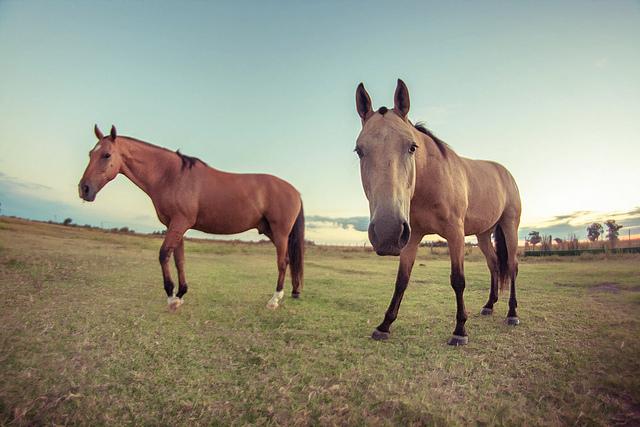Is the horse looking at the camera?
Answer briefly. Yes. Does the grass need to be trimmed?
Keep it brief. No. Are the horses walking?
Keep it brief. No. Has the horse been tied?
Short answer required. No. Are the shadows overpowering the photo?
Concise answer only. No. What is the horses looking at?
Answer briefly. Camera. Are the horses on a hillside?
Short answer required. No. 